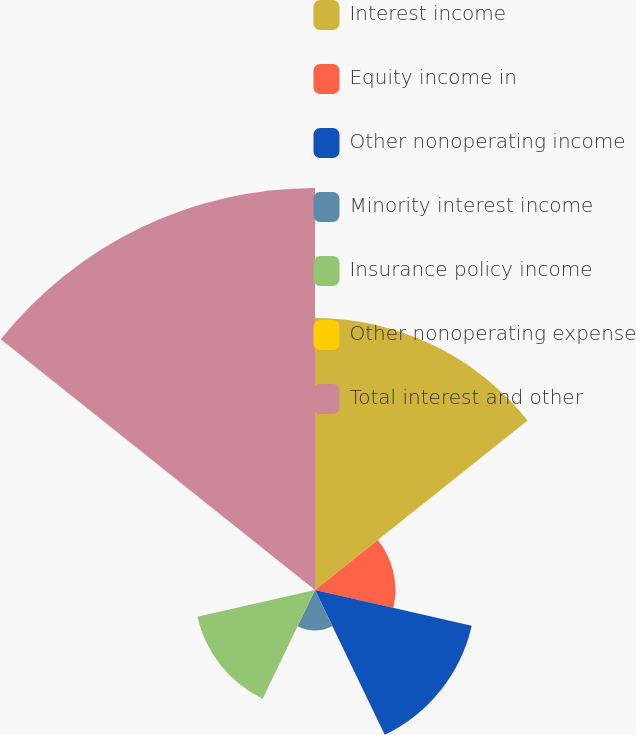Convert chart. <chart><loc_0><loc_0><loc_500><loc_500><pie_chart><fcel>Interest income<fcel>Equity income in<fcel>Other nonoperating income<fcel>Minority interest income<fcel>Insurance policy income<fcel>Other nonoperating expense<fcel>Total interest and other<nl><fcel>25.27%<fcel>7.47%<fcel>14.94%<fcel>3.74%<fcel>11.21%<fcel>0.0%<fcel>37.36%<nl></chart> 